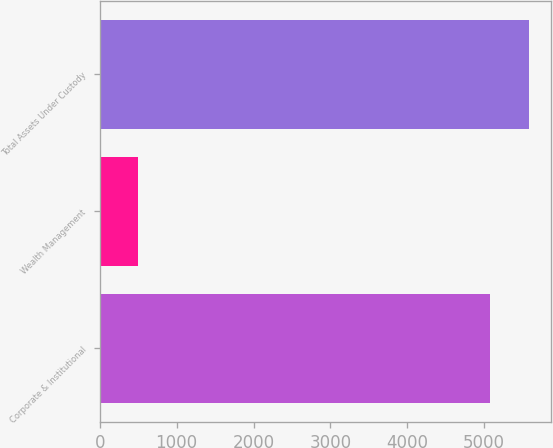<chart> <loc_0><loc_0><loc_500><loc_500><bar_chart><fcel>Corporate & Institutional<fcel>Wealth Management<fcel>Total Assets Under Custody<nl><fcel>5079.7<fcel>496<fcel>5587.67<nl></chart> 